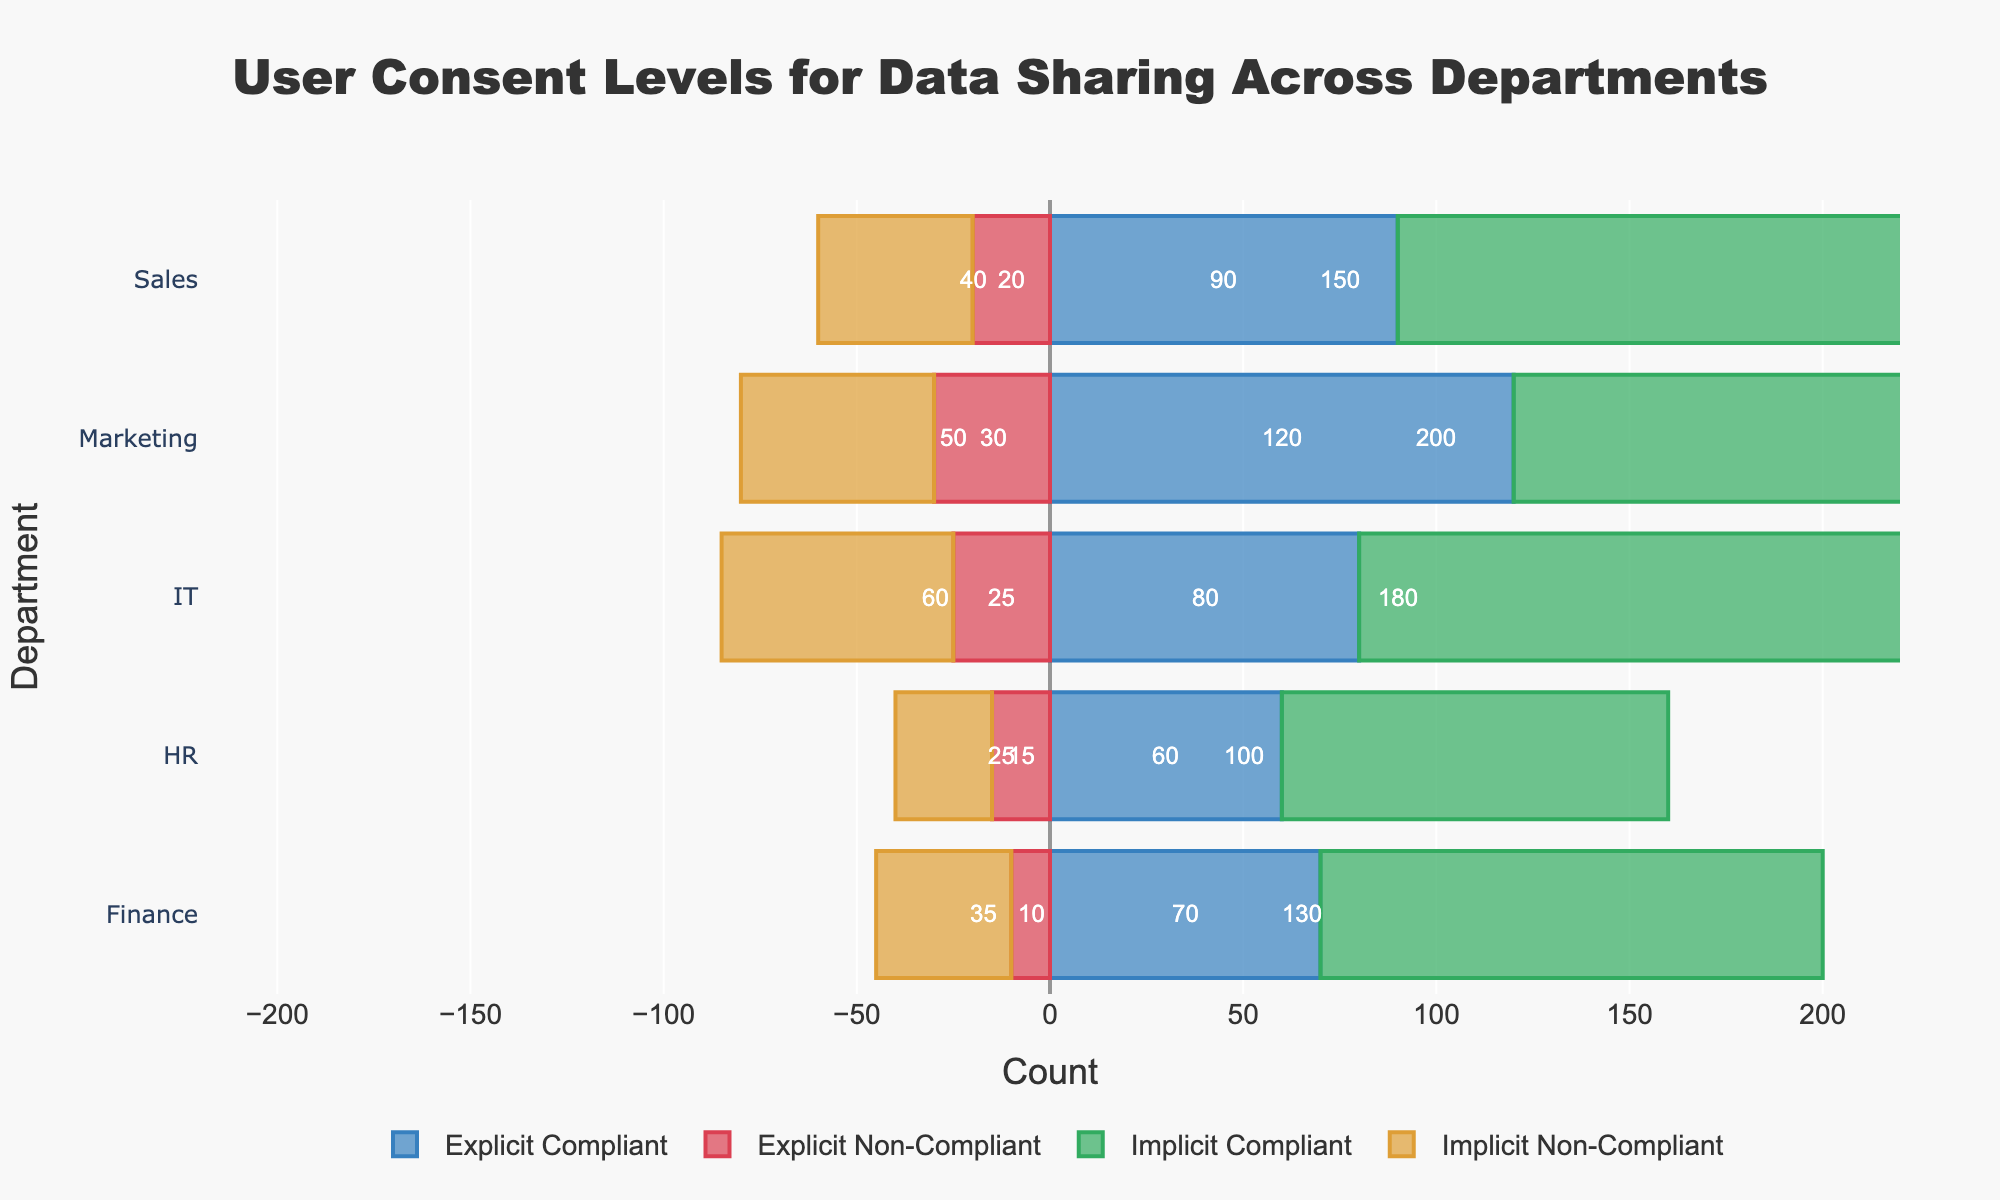Which department has the highest number of explicit non-compliant cases? To find this, compare the lengths of the red bars for explicit non-compliant cases across all departments. The longest red bar represents the highest count.
Answer: Marketing Which department has a higher count of implicit compliant cases, Marketing or IT? Compare the lengths of the green bars for implicit compliant cases in both Marketing and IT. IT's green bar is longer than Marketing's.
Answer: IT What is the total count of explicit compliant and non-compliant cases for the Sales department? Add the values for explicit compliant and non-compliant cases for the Sales department: 90 (compliant) + 20 (non-compliant) = 110.
Answer: 110 Is the total number of implicit non-compliant cases in HR greater or less than that in Finance? Compare the absolute lengths of the orange bars for implicit non-compliant cases in HR and Finance. HR has 25 and Finance has 35; 25 is less than 35.
Answer: Less Which department has the smallest difference between explicit compliant and explicit non-compliant counts? Calculate the differences for each department and find the smallest one: Marketing (120-30=90), Sales (90-20=70), HR (60-15=45), IT (80-25=55), Finance (70-10=60). HR has the smallest difference with 45.
Answer: HR How many more implicit compliant cases are there in IT compared to the implicit non-compliant cases in the same department? Subtract the number of implicit non-compliant cases in IT from the implicit compliant cases: 180 (compliant) - 60 (non-compliant) = 120.
Answer: 120 What is the ratio of explicit compliant cases to implicit compliant cases in the Marketing department? Divide the number of explicit compliant cases by implicit compliant cases in Marketing: 120 / 200 = 0.6.
Answer: 0.6 Which department has the most balanced explicit and implicit consent compliance status? Look for the department where the lengths of compliant bars (both explicit and implicit) and non-compliant bars (both explicit and implicit) are closest to each other. Sales shows the most balance.
Answer: Sales Among all departments, which one has the highest total count of both explicit and implicit compliant cases combined? Sum the explicit and implicit compliant cases and compare for each department: Marketing (120+200=320), Sales (90+150=240), HR (60+100=160), IT (80+180=260), Finance (70+130=200). Marketing has the highest total.
Answer: Marketing 